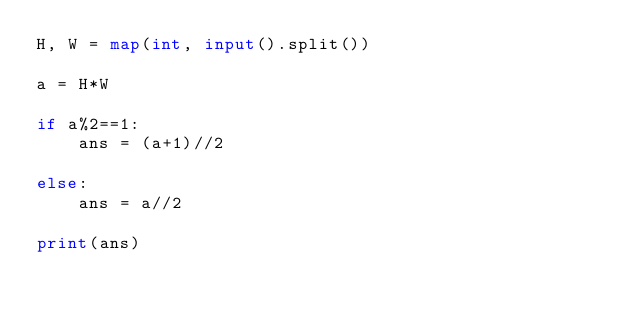Convert code to text. <code><loc_0><loc_0><loc_500><loc_500><_Python_>H, W = map(int, input().split())

a = H*W

if a%2==1:
    ans = (a+1)//2

else:
    ans = a//2

print(ans)</code> 